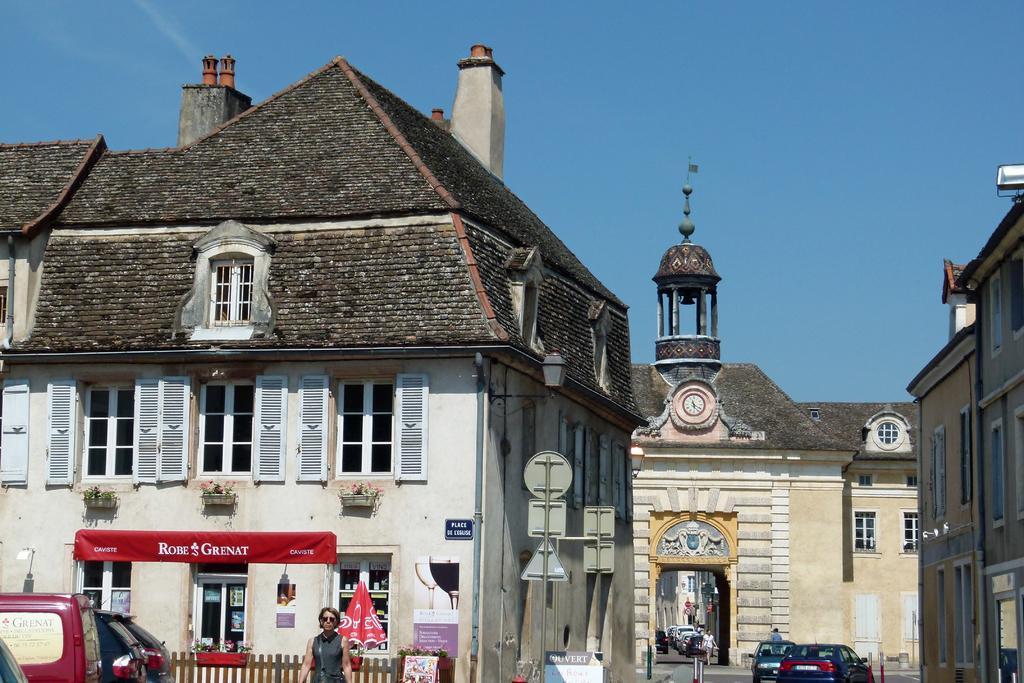Can you describe this image briefly? This image is taken outdoors. At the top of the image there is the sky. In the middle of the image there are three buildings with walls, windows, doors, grills and roofs. There is a clock on the wall. There are a few boards with text on them. A few cars are moving on the road and two women are walking. There is a closed umbrella. There is a wooden fence. On the left side of the image a few cars are parked on the road. There are a few plants in the pots. 